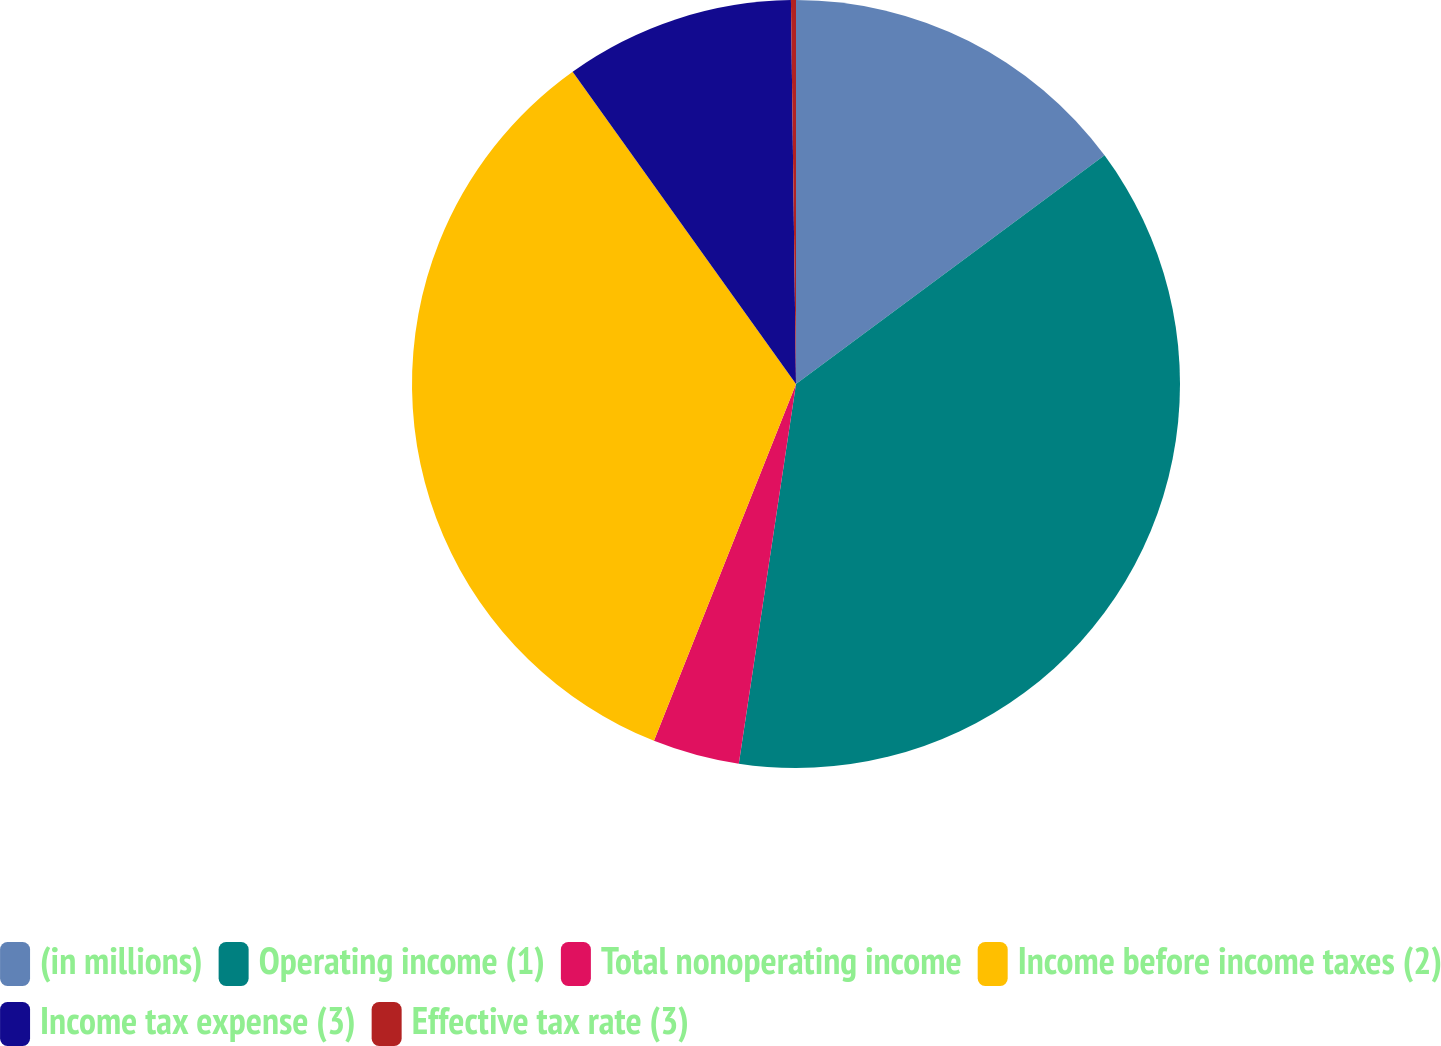Convert chart. <chart><loc_0><loc_0><loc_500><loc_500><pie_chart><fcel>(in millions)<fcel>Operating income (1)<fcel>Total nonoperating income<fcel>Income before income taxes (2)<fcel>Income tax expense (3)<fcel>Effective tax rate (3)<nl><fcel>14.85%<fcel>37.53%<fcel>3.65%<fcel>34.09%<fcel>9.67%<fcel>0.21%<nl></chart> 